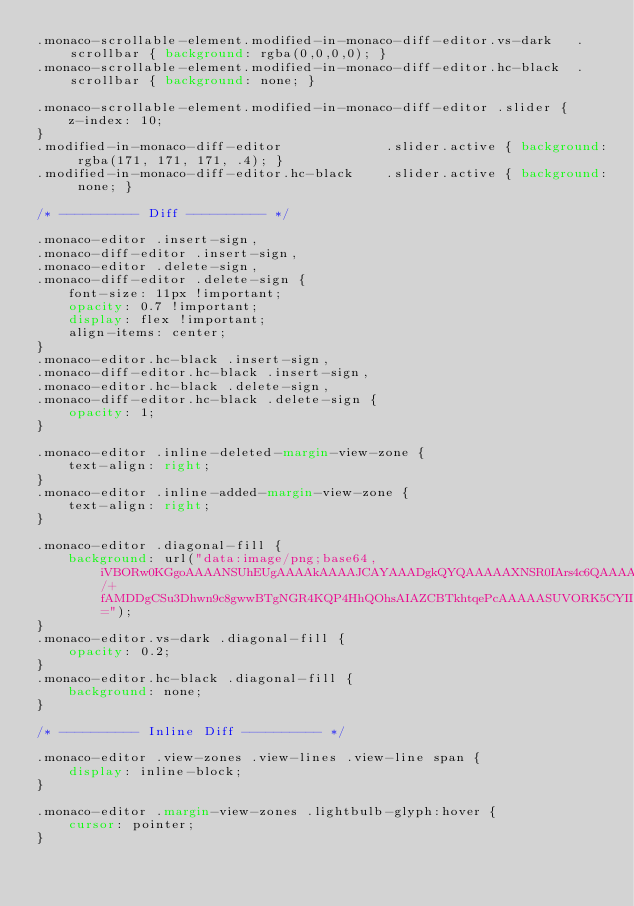<code> <loc_0><loc_0><loc_500><loc_500><_CSS_>.monaco-scrollable-element.modified-in-monaco-diff-editor.vs-dark	.scrollbar { background: rgba(0,0,0,0); }
.monaco-scrollable-element.modified-in-monaco-diff-editor.hc-black	.scrollbar { background: none; }

.monaco-scrollable-element.modified-in-monaco-diff-editor .slider {
	z-index: 10;
}
.modified-in-monaco-diff-editor				.slider.active { background: rgba(171, 171, 171, .4); }
.modified-in-monaco-diff-editor.hc-black	.slider.active { background: none; }

/* ---------- Diff ---------- */

.monaco-editor .insert-sign,
.monaco-diff-editor .insert-sign,
.monaco-editor .delete-sign,
.monaco-diff-editor .delete-sign {
	font-size: 11px !important;
	opacity: 0.7 !important;
	display: flex !important;
	align-items: center;
}
.monaco-editor.hc-black .insert-sign,
.monaco-diff-editor.hc-black .insert-sign,
.monaco-editor.hc-black .delete-sign,
.monaco-diff-editor.hc-black .delete-sign {
	opacity: 1;
}

.monaco-editor .inline-deleted-margin-view-zone {
	text-align: right;
}
.monaco-editor .inline-added-margin-view-zone {
	text-align: right;
}

.monaco-editor .diagonal-fill {
	background: url("data:image/png;base64,iVBORw0KGgoAAAANSUhEUgAAAAkAAAAJCAYAAADgkQYQAAAAAXNSR0IArs4c6QAAAARnQU1BAACxjwv8YQUAAAAJcEhZcwAADsMAAA7DAcdvqGQAAAAadEVYdFNvZnR3YXJlAFBhaW50Lk5FVCB2My41LjEwMPRyoQAAAChJREFUKFNjOH/+fAMDDgCSu3Dhwn9c8gwwBTgNGR4KQP4HhQOhsAIAZCBTkhtqePcAAAAASUVORK5CYII=");
}
.monaco-editor.vs-dark .diagonal-fill {
	opacity: 0.2;
}
.monaco-editor.hc-black .diagonal-fill {
	background: none;
}

/* ---------- Inline Diff ---------- */

.monaco-editor .view-zones .view-lines .view-line span {
	display: inline-block;
}

.monaco-editor .margin-view-zones .lightbulb-glyph:hover {
	cursor: pointer;
}
</code> 